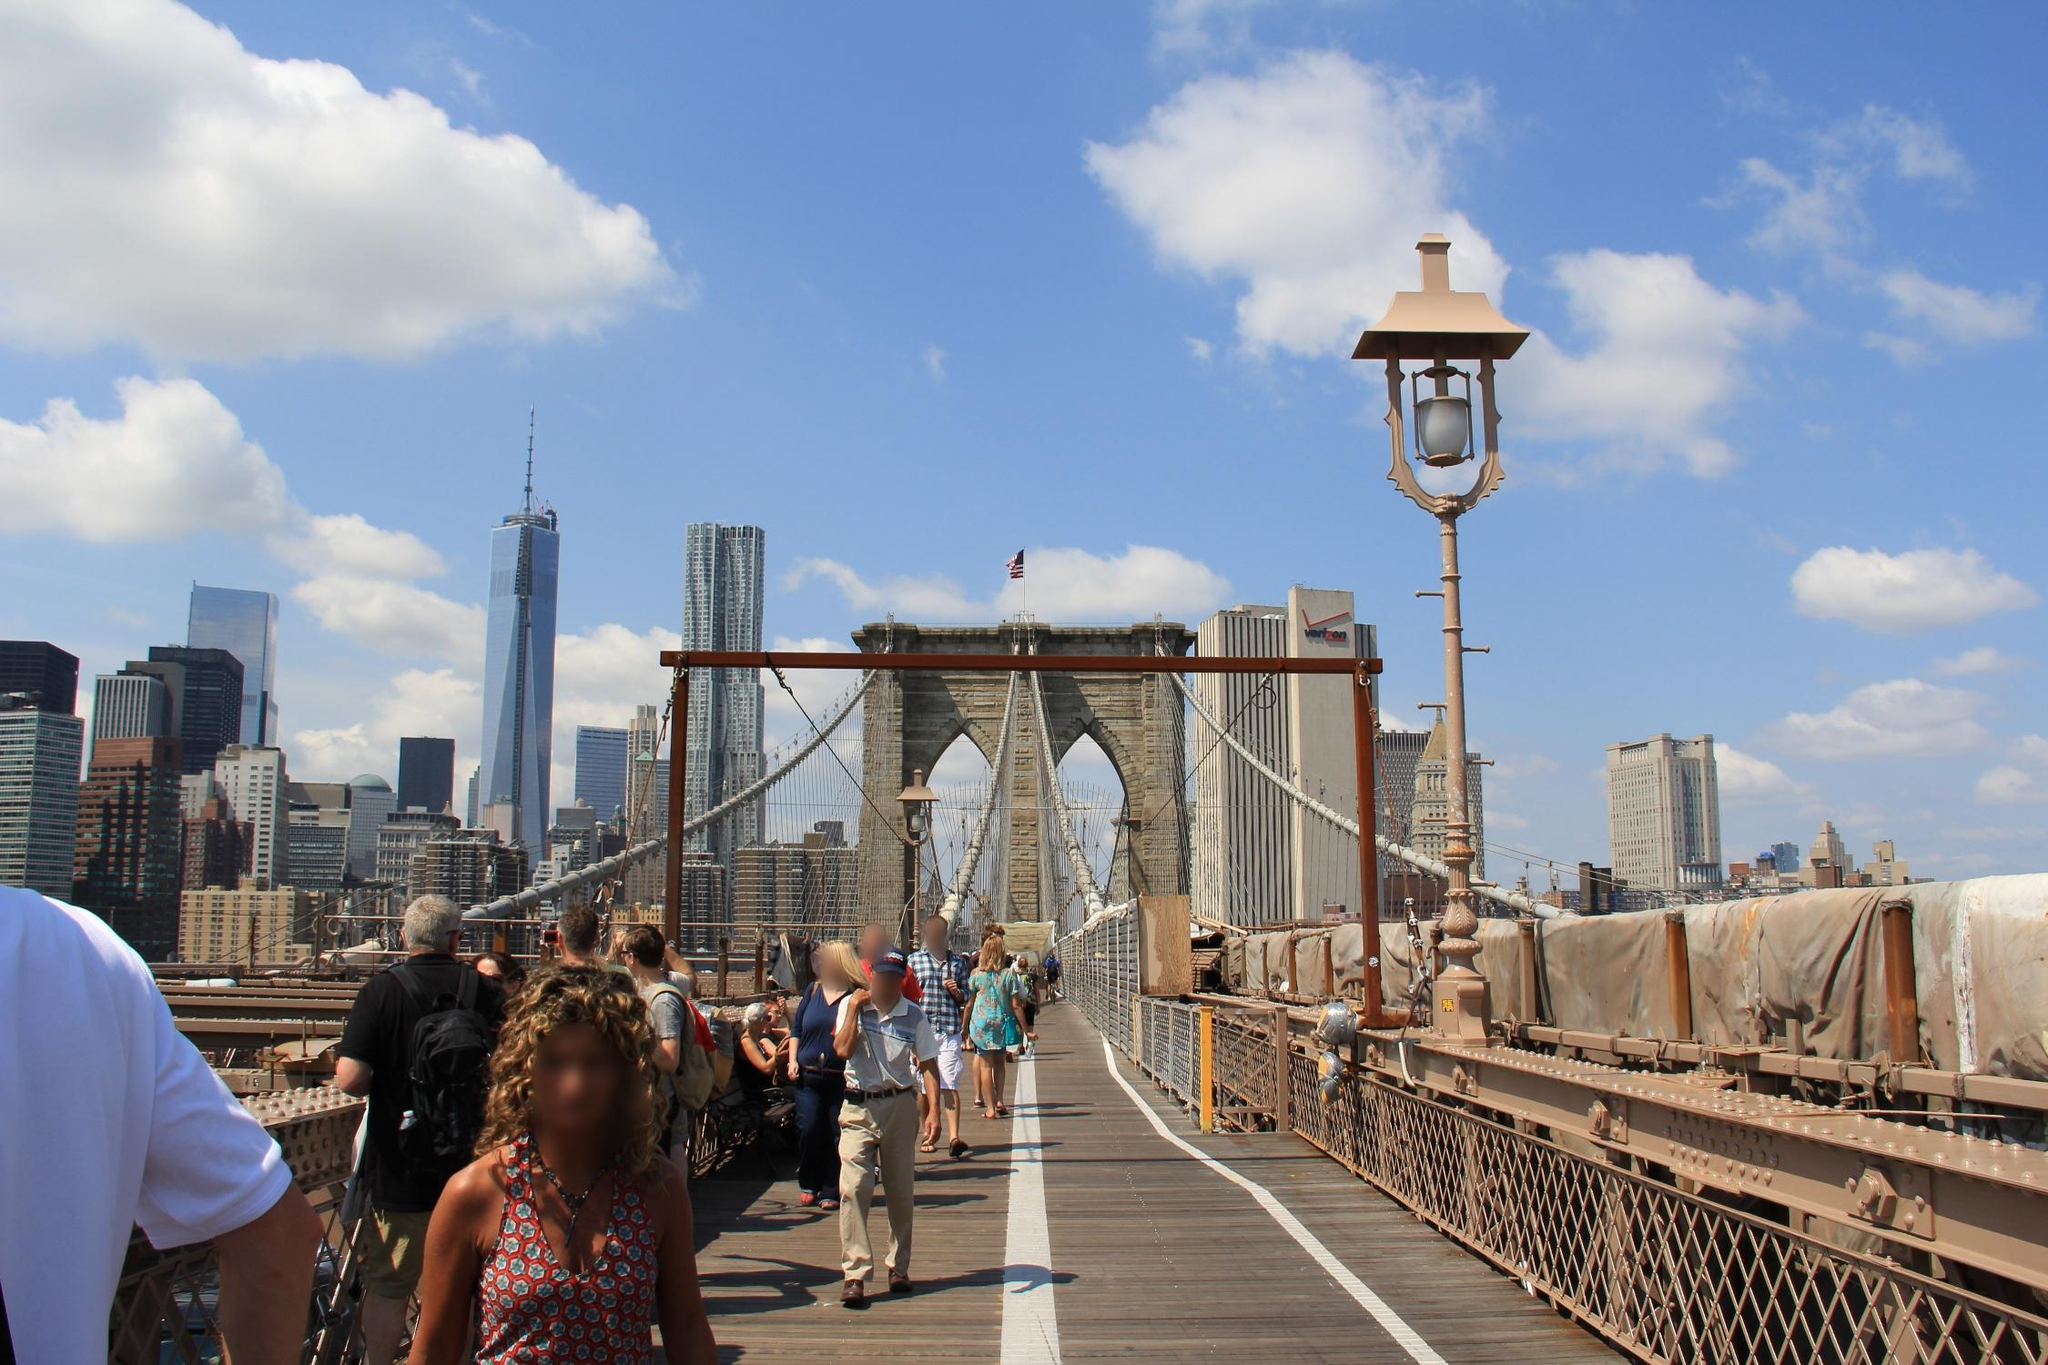If you could add an unexpected element to this image, what would it be and why? Adding a whimsical hot air balloon drifting just above the bridge would introduce an unexpected yet enchanting element to the image. The vibrant colors of the balloon would contrast beautifully with the blue sky and the neutral tones of the bridge. It would evoke a sense of wonder and fantasy, sparking the imagination of viewers and creating a visual narrative of adventure and exploration. The hot air balloon would symbolize freedom and curiosity, elements that harmonize with the spirit of New York City as a place of endless possibilities. 